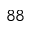Convert formula to latex. <formula><loc_0><loc_0><loc_500><loc_500>^ { 8 8 }</formula> 